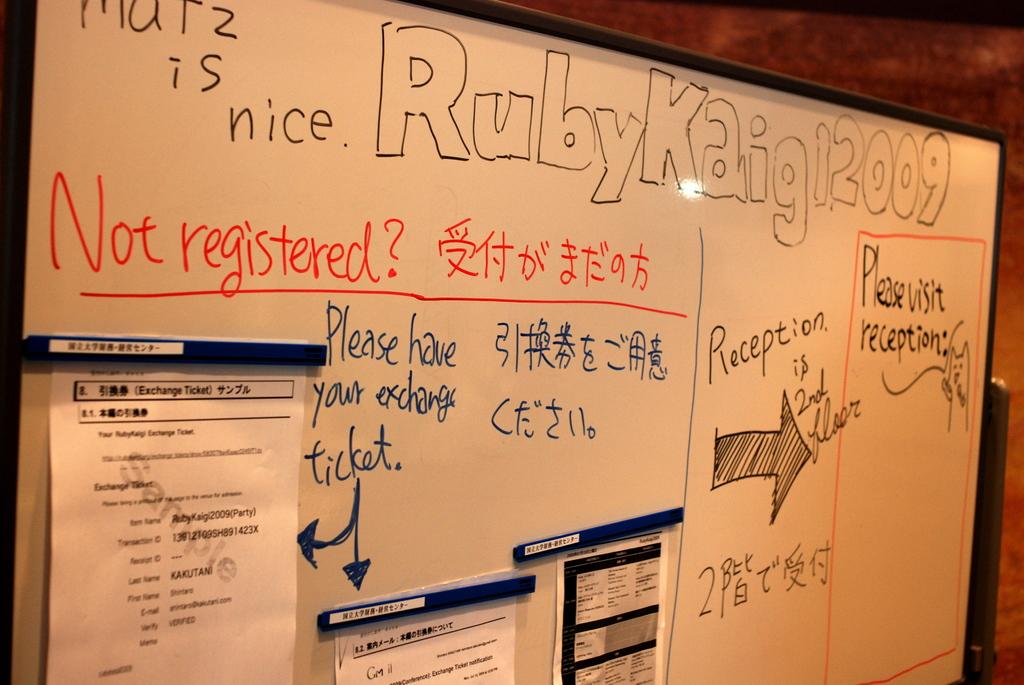What is the year on the top right of the board?
Your answer should be compact. 2009. What floor is reception found on?
Make the answer very short. 2nd. 